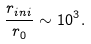Convert formula to latex. <formula><loc_0><loc_0><loc_500><loc_500>\frac { r _ { i n i } } { r _ { 0 } } \sim 1 0 ^ { 3 } .</formula> 